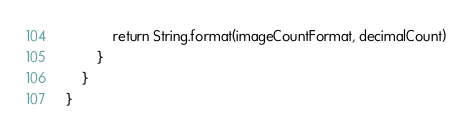Convert code to text. <code><loc_0><loc_0><loc_500><loc_500><_Kotlin_>            return String.format(imageCountFormat, decimalCount)
        }
    }
}</code> 